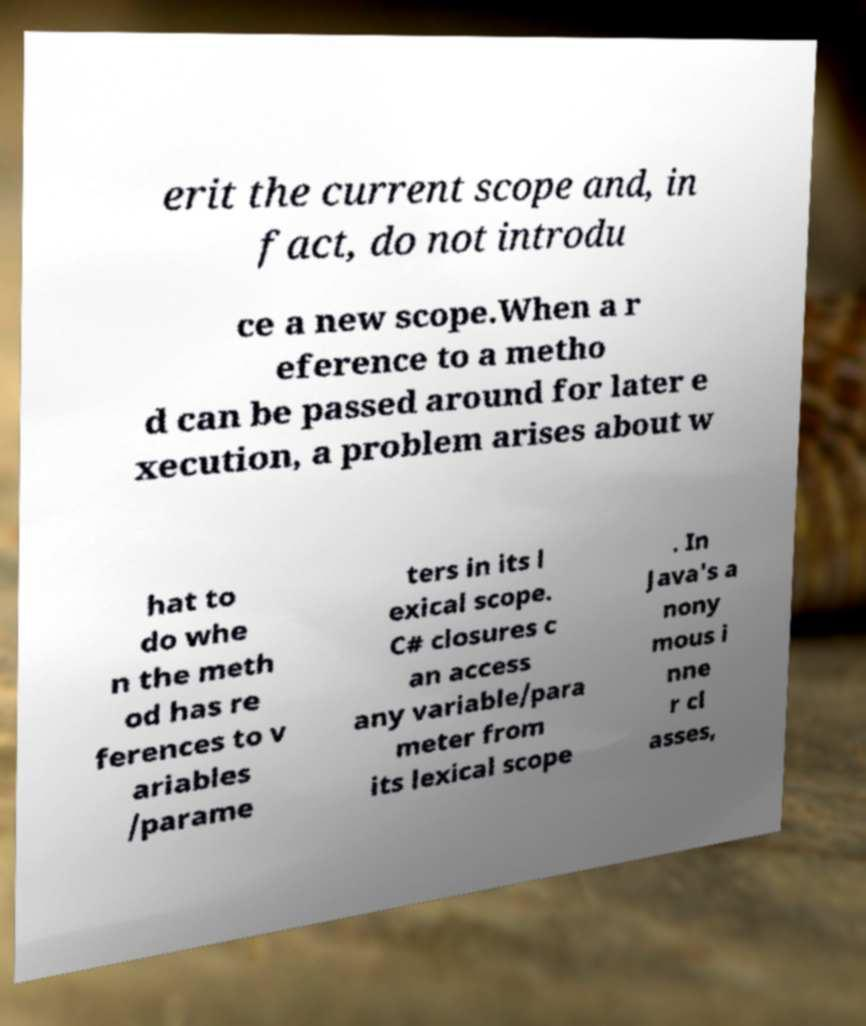Please read and relay the text visible in this image. What does it say? erit the current scope and, in fact, do not introdu ce a new scope.When a r eference to a metho d can be passed around for later e xecution, a problem arises about w hat to do whe n the meth od has re ferences to v ariables /parame ters in its l exical scope. C# closures c an access any variable/para meter from its lexical scope . In Java's a nony mous i nne r cl asses, 